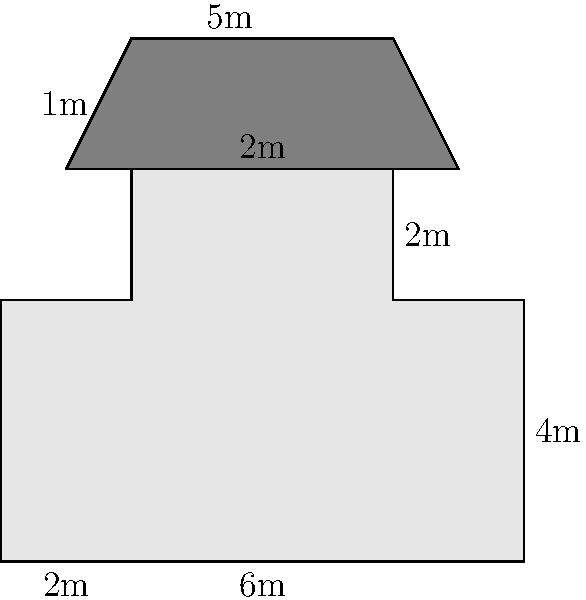Calculate the perimeter of this stylized gas station silhouette inspired by Ed Ruscha's iconic artwork. All measurements are in meters. To calculate the perimeter, we need to sum up all the exterior sides of the gas station silhouette:

1. Bottom edge: $8$ m
2. Right side (lower part): $4$ m
3. Right side (upper part): $2$ m
4. Top of main structure: $2$ m
5. Left side of roof: $1$ m
6. Top of roof: $5$ m
7. Right side of roof: $1$ m
8. Left side (upper part): $2$ m
9. Left side (lower part): $4$ m

Sum all these lengths:

$$8 + 4 + 2 + 2 + 1 + 5 + 1 + 2 + 4 = 29$$

Therefore, the total perimeter is $29$ meters.
Answer: $29$ m 